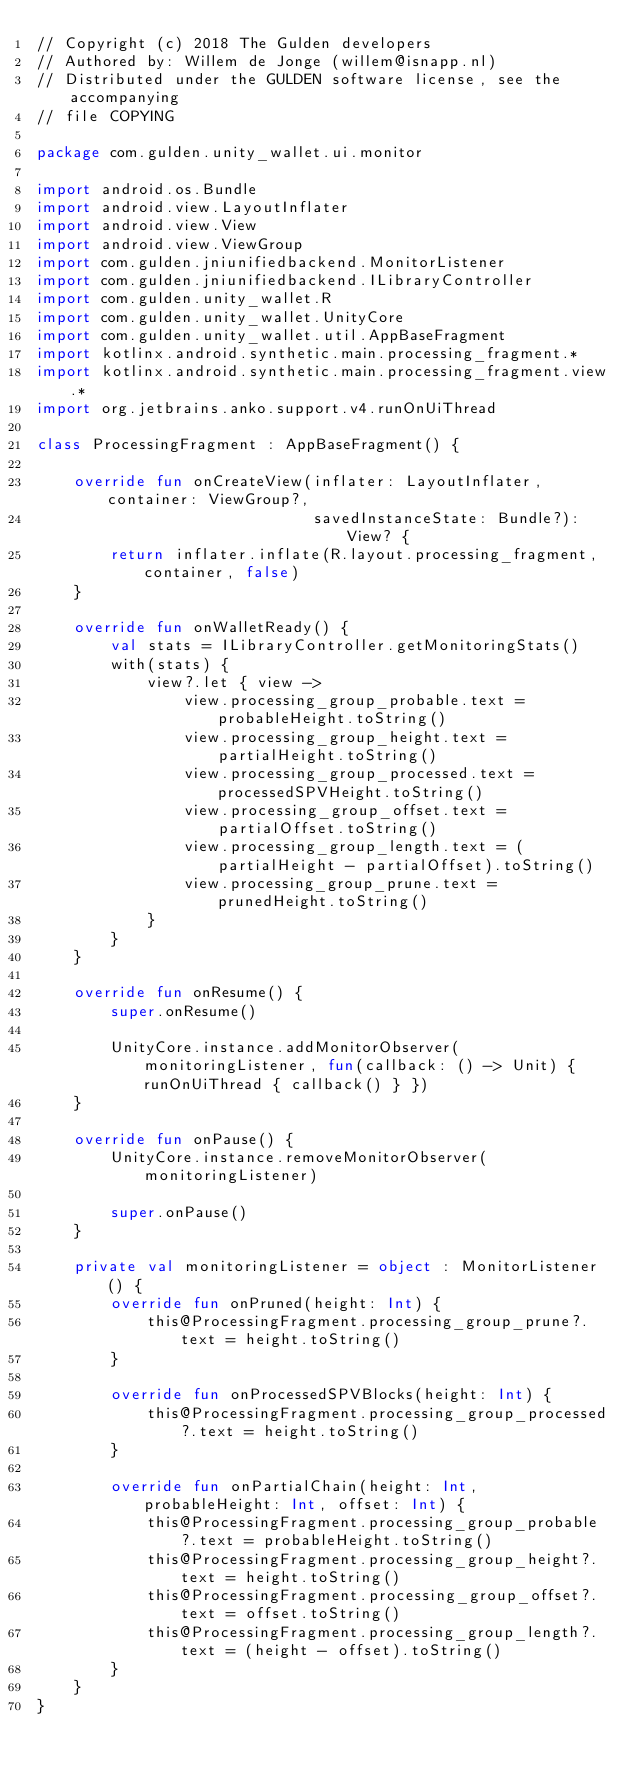<code> <loc_0><loc_0><loc_500><loc_500><_Kotlin_>// Copyright (c) 2018 The Gulden developers
// Authored by: Willem de Jonge (willem@isnapp.nl)
// Distributed under the GULDEN software license, see the accompanying
// file COPYING

package com.gulden.unity_wallet.ui.monitor

import android.os.Bundle
import android.view.LayoutInflater
import android.view.View
import android.view.ViewGroup
import com.gulden.jniunifiedbackend.MonitorListener
import com.gulden.jniunifiedbackend.ILibraryController
import com.gulden.unity_wallet.R
import com.gulden.unity_wallet.UnityCore
import com.gulden.unity_wallet.util.AppBaseFragment
import kotlinx.android.synthetic.main.processing_fragment.*
import kotlinx.android.synthetic.main.processing_fragment.view.*
import org.jetbrains.anko.support.v4.runOnUiThread

class ProcessingFragment : AppBaseFragment() {

    override fun onCreateView(inflater: LayoutInflater, container: ViewGroup?,
                              savedInstanceState: Bundle?): View? {
        return inflater.inflate(R.layout.processing_fragment, container, false)
    }

    override fun onWalletReady() {
        val stats = ILibraryController.getMonitoringStats()
        with(stats) {
            view?.let { view ->
                view.processing_group_probable.text = probableHeight.toString()
                view.processing_group_height.text = partialHeight.toString()
                view.processing_group_processed.text = processedSPVHeight.toString()
                view.processing_group_offset.text = partialOffset.toString()
                view.processing_group_length.text = (partialHeight - partialOffset).toString()
                view.processing_group_prune.text = prunedHeight.toString()
            }
        }
    }

    override fun onResume() {
        super.onResume()

        UnityCore.instance.addMonitorObserver(monitoringListener, fun(callback: () -> Unit) { runOnUiThread { callback() } })
    }

    override fun onPause() {
        UnityCore.instance.removeMonitorObserver(monitoringListener)

        super.onPause()
    }

    private val monitoringListener = object : MonitorListener() {
        override fun onPruned(height: Int) {
            this@ProcessingFragment.processing_group_prune?.text = height.toString()
        }

        override fun onProcessedSPVBlocks(height: Int) {
            this@ProcessingFragment.processing_group_processed?.text = height.toString()
        }

        override fun onPartialChain(height: Int, probableHeight: Int, offset: Int) {
            this@ProcessingFragment.processing_group_probable?.text = probableHeight.toString()
            this@ProcessingFragment.processing_group_height?.text = height.toString()
            this@ProcessingFragment.processing_group_offset?.text = offset.toString()
            this@ProcessingFragment.processing_group_length?.text = (height - offset).toString()
        }
    }
}
</code> 